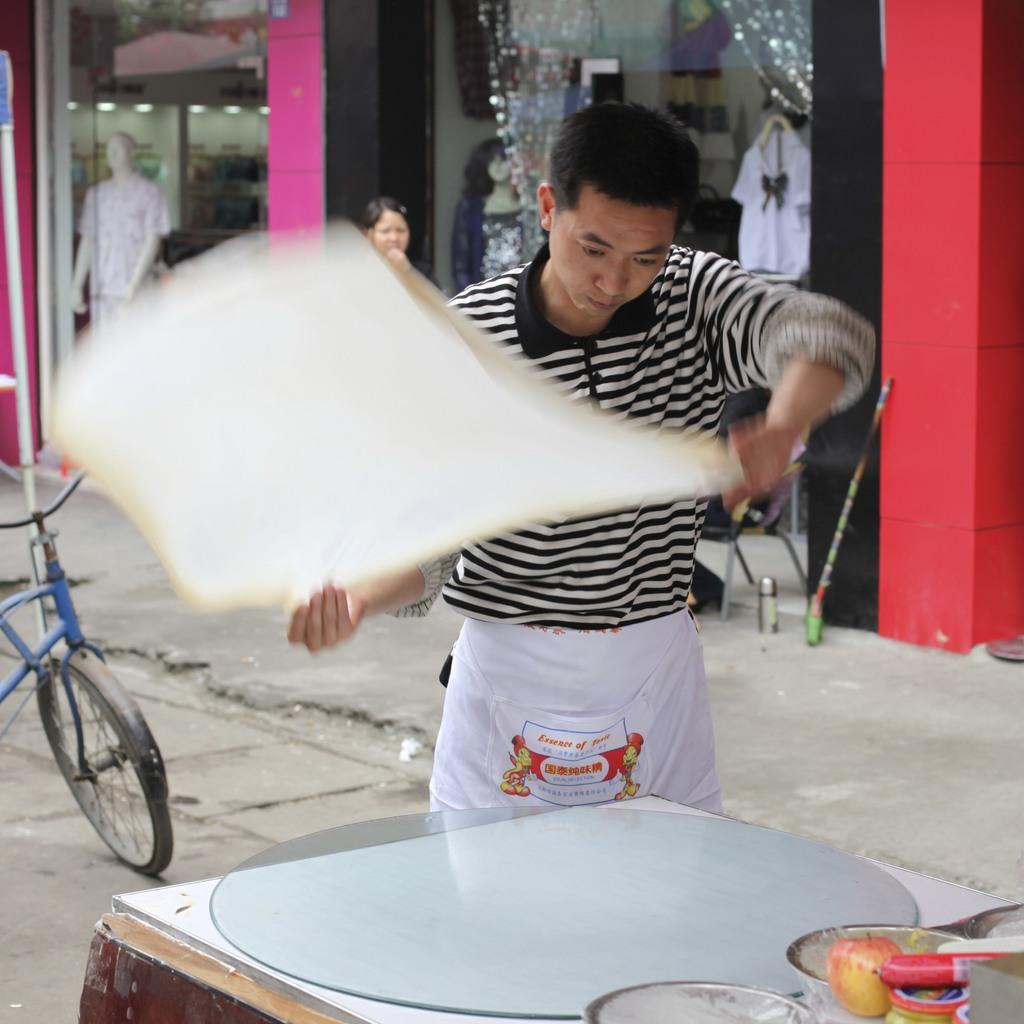What is the gender of the person in the image? There is a man in the image. What is the man doing in the image? The man is standing and preparing a food item with his hands. What other object can be seen in the image? There is a bicycle in the image. Can you describe the woman in the image? The woman is standing in the image. What type of establishment is visible in the image? There is a store visible in the image. Where is the faucet located in the image? There is no faucet present in the image. What achievements has the woman accomplished, as seen in the image? The image does not provide information about the woman's achievements. 